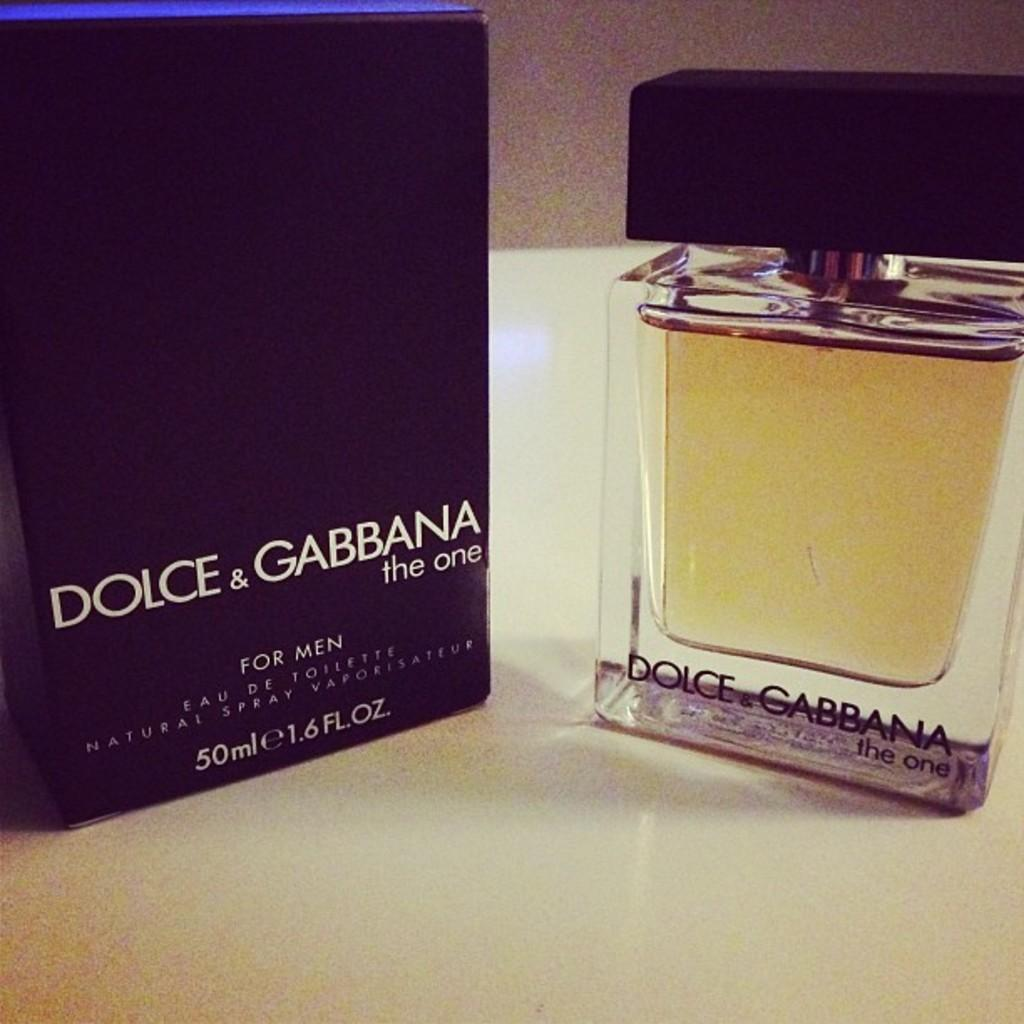<image>
Provide a brief description of the given image. Cologne bottle next to a black box which says Dolce & Gabbana. 